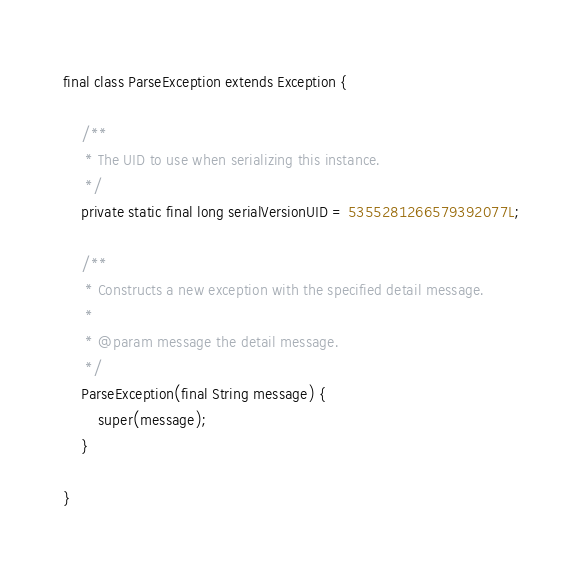<code> <loc_0><loc_0><loc_500><loc_500><_Java_>final class ParseException extends Exception {

    /**
     * The UID to use when serializing this instance.
     */
    private static final long serialVersionUID = 5355281266579392077L;

    /**
     * Constructs a new exception with the specified detail message.
     *
     * @param message the detail message.
     */
    ParseException(final String message) {
        super(message);
    }

}
</code> 